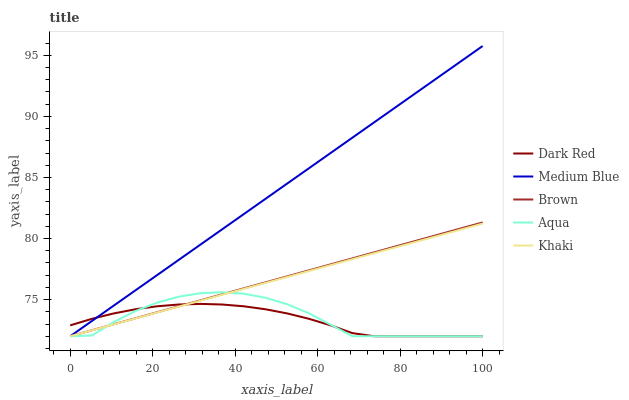Does Dark Red have the minimum area under the curve?
Answer yes or no. Yes. Does Medium Blue have the maximum area under the curve?
Answer yes or no. Yes. Does Khaki have the minimum area under the curve?
Answer yes or no. No. Does Khaki have the maximum area under the curve?
Answer yes or no. No. Is Khaki the smoothest?
Answer yes or no. Yes. Is Aqua the roughest?
Answer yes or no. Yes. Is Dark Red the smoothest?
Answer yes or no. No. Is Dark Red the roughest?
Answer yes or no. No. Does Aqua have the lowest value?
Answer yes or no. Yes. Does Medium Blue have the highest value?
Answer yes or no. Yes. Does Khaki have the highest value?
Answer yes or no. No. Does Dark Red intersect Khaki?
Answer yes or no. Yes. Is Dark Red less than Khaki?
Answer yes or no. No. Is Dark Red greater than Khaki?
Answer yes or no. No. 